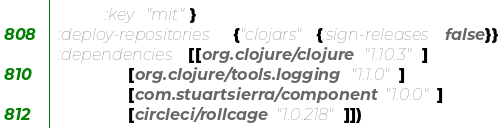<code> <loc_0><loc_0><loc_500><loc_500><_Clojure_>            :key "mit"}
  :deploy-repositories {"clojars" {:sign-releases false}}
  :dependencies [[org.clojure/clojure "1.10.3"]
                 [org.clojure/tools.logging "1.1.0"]
                 [com.stuartsierra/component "1.0.0"]
                 [circleci/rollcage "1.0.218"]])
</code> 